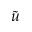<formula> <loc_0><loc_0><loc_500><loc_500>\tilde { u }</formula> 